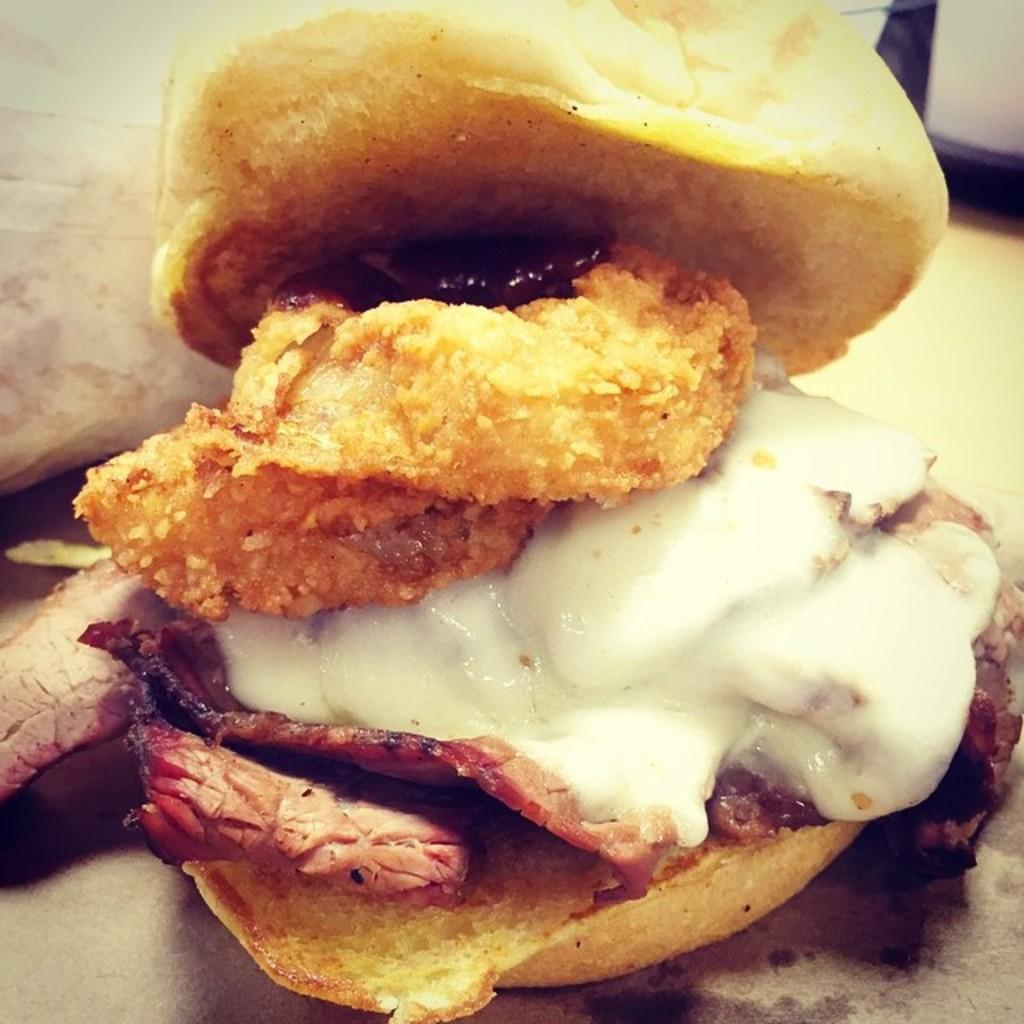What type of food is present in the image? There is food in the image. What specific components can be identified in the food? The food contains breads and cream. What type of string can be seen holding the cactus in the image? There is no string or cactus present in the image; it features food containing breads and cream. 